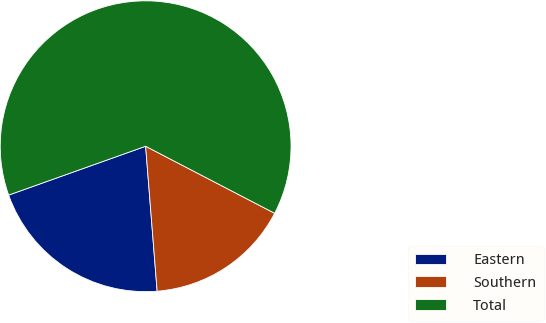<chart> <loc_0><loc_0><loc_500><loc_500><pie_chart><fcel>Eastern<fcel>Southern<fcel>Total<nl><fcel>20.81%<fcel>16.11%<fcel>63.08%<nl></chart> 